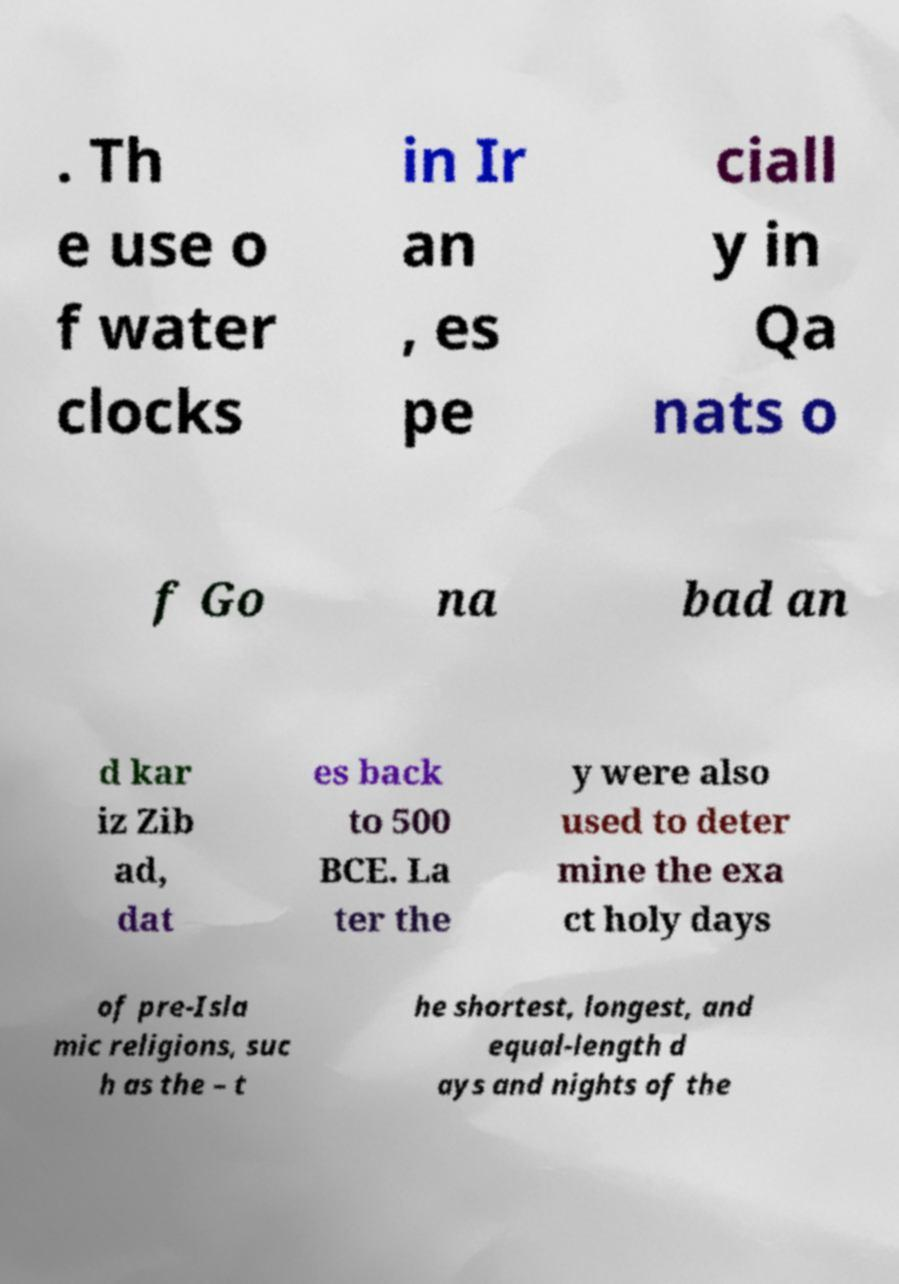For documentation purposes, I need the text within this image transcribed. Could you provide that? . Th e use o f water clocks in Ir an , es pe ciall y in Qa nats o f Go na bad an d kar iz Zib ad, dat es back to 500 BCE. La ter the y were also used to deter mine the exa ct holy days of pre-Isla mic religions, suc h as the – t he shortest, longest, and equal-length d ays and nights of the 